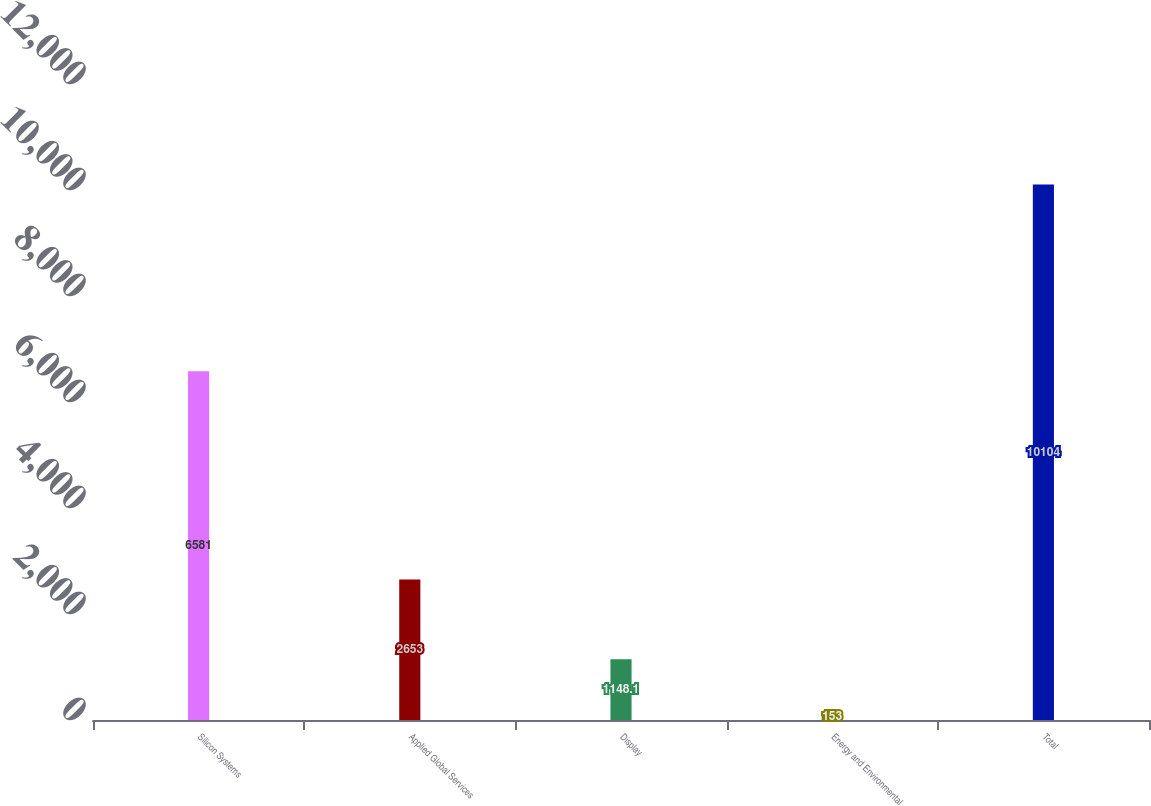<chart> <loc_0><loc_0><loc_500><loc_500><bar_chart><fcel>Silicon Systems<fcel>Applied Global Services<fcel>Display<fcel>Energy and Environmental<fcel>Total<nl><fcel>6581<fcel>2653<fcel>1148.1<fcel>153<fcel>10104<nl></chart> 